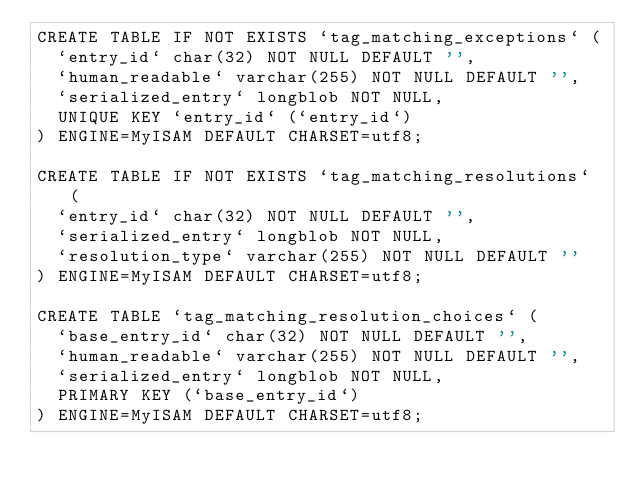Convert code to text. <code><loc_0><loc_0><loc_500><loc_500><_SQL_>CREATE TABLE IF NOT EXISTS `tag_matching_exceptions` (
  `entry_id` char(32) NOT NULL DEFAULT '',
  `human_readable` varchar(255) NOT NULL DEFAULT '',
  `serialized_entry` longblob NOT NULL,
  UNIQUE KEY `entry_id` (`entry_id`)
) ENGINE=MyISAM DEFAULT CHARSET=utf8;

CREATE TABLE IF NOT EXISTS `tag_matching_resolutions` (
  `entry_id` char(32) NOT NULL DEFAULT '',
  `serialized_entry` longblob NOT NULL,
  `resolution_type` varchar(255) NOT NULL DEFAULT ''
) ENGINE=MyISAM DEFAULT CHARSET=utf8;

CREATE TABLE `tag_matching_resolution_choices` (
  `base_entry_id` char(32) NOT NULL DEFAULT '',
  `human_readable` varchar(255) NOT NULL DEFAULT '',
  `serialized_entry` longblob NOT NULL,
  PRIMARY KEY (`base_entry_id`)
) ENGINE=MyISAM DEFAULT CHARSET=utf8;</code> 